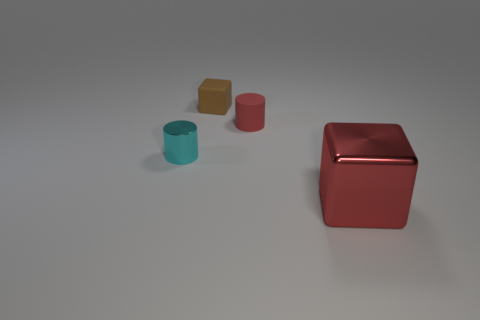Is there anything else of the same color as the large cube? Yes, the smaller cube on the left appears to be the same color as the larger cube. 